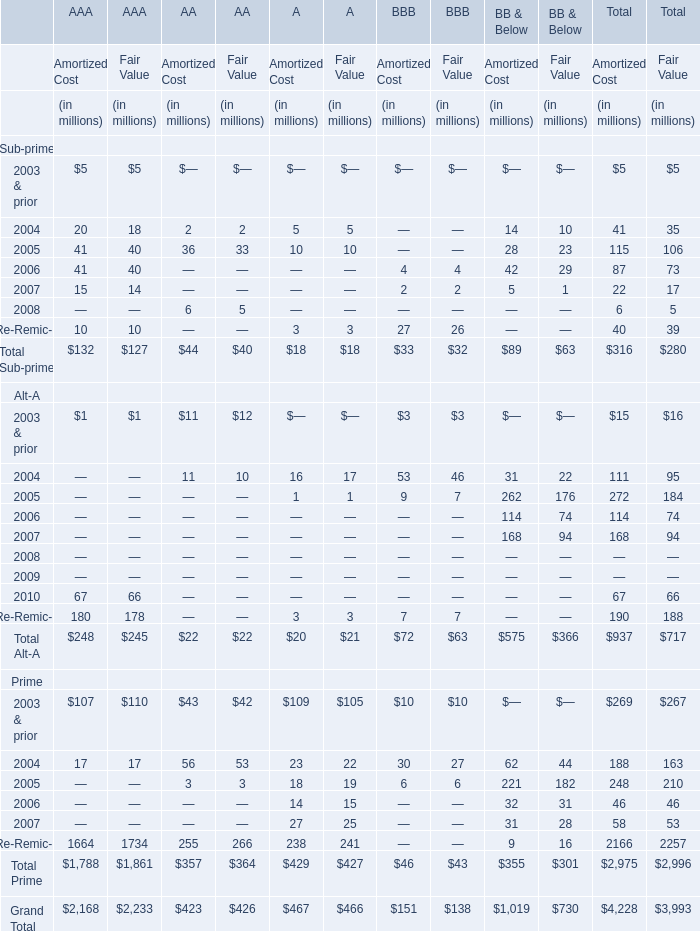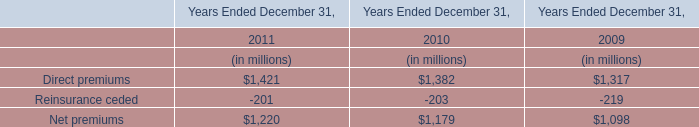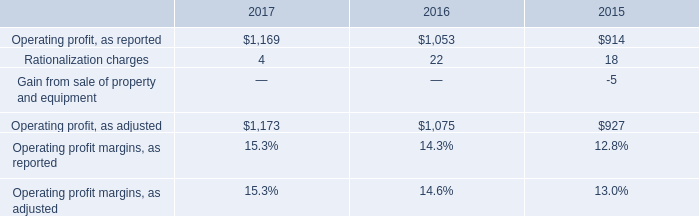What's the total amount of Sub-prime of AAA with Amortized Cost in 2004? (in dollars in millions) 
Answer: 20. 